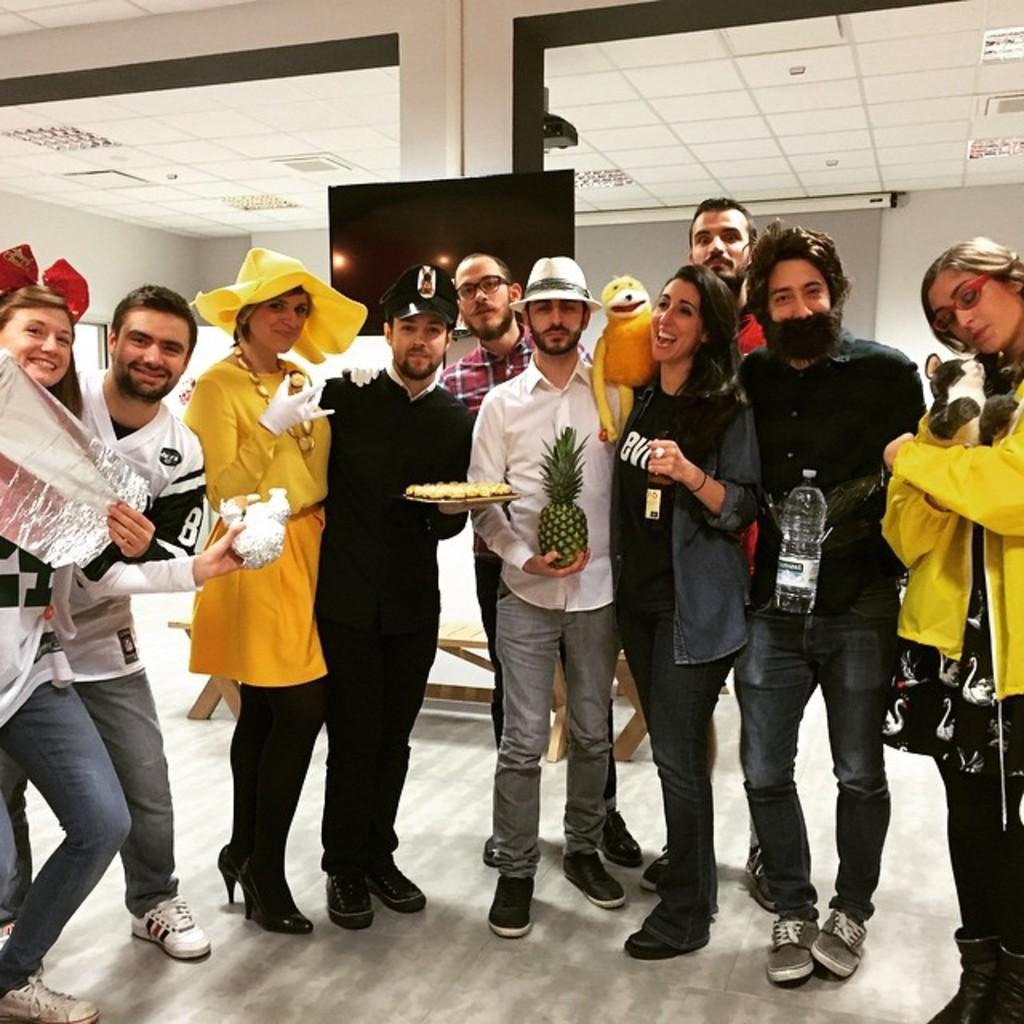Please provide a concise description of this image. In this picture I can see group of people standing, there are few persons holding some objects, there is a television, projector screen, projector, there are lights and some other objects. 